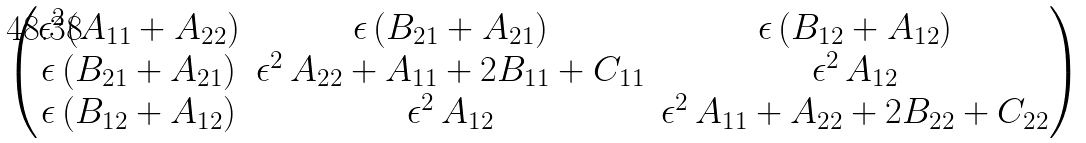<formula> <loc_0><loc_0><loc_500><loc_500>\begin{pmatrix} \epsilon ^ { 2 } ( A _ { 1 1 } + A _ { 2 2 } ) & \epsilon \, ( B _ { 2 1 } + A _ { 2 1 } ) & \epsilon \, ( B _ { 1 2 } + A _ { 1 2 } ) \\ \epsilon \, ( B _ { 2 1 } + A _ { 2 1 } ) & \epsilon ^ { 2 } \, A _ { 2 2 } + A _ { 1 1 } + 2 B _ { 1 1 } + C _ { 1 1 } & \epsilon ^ { 2 } \, A _ { 1 2 } \\ \epsilon \, ( B _ { 1 2 } + A _ { 1 2 } ) & \epsilon ^ { 2 } \, A _ { 1 2 } & \epsilon ^ { 2 } \, A _ { 1 1 } + A _ { 2 2 } + 2 B _ { 2 2 } + C _ { 2 2 } \end{pmatrix}</formula> 